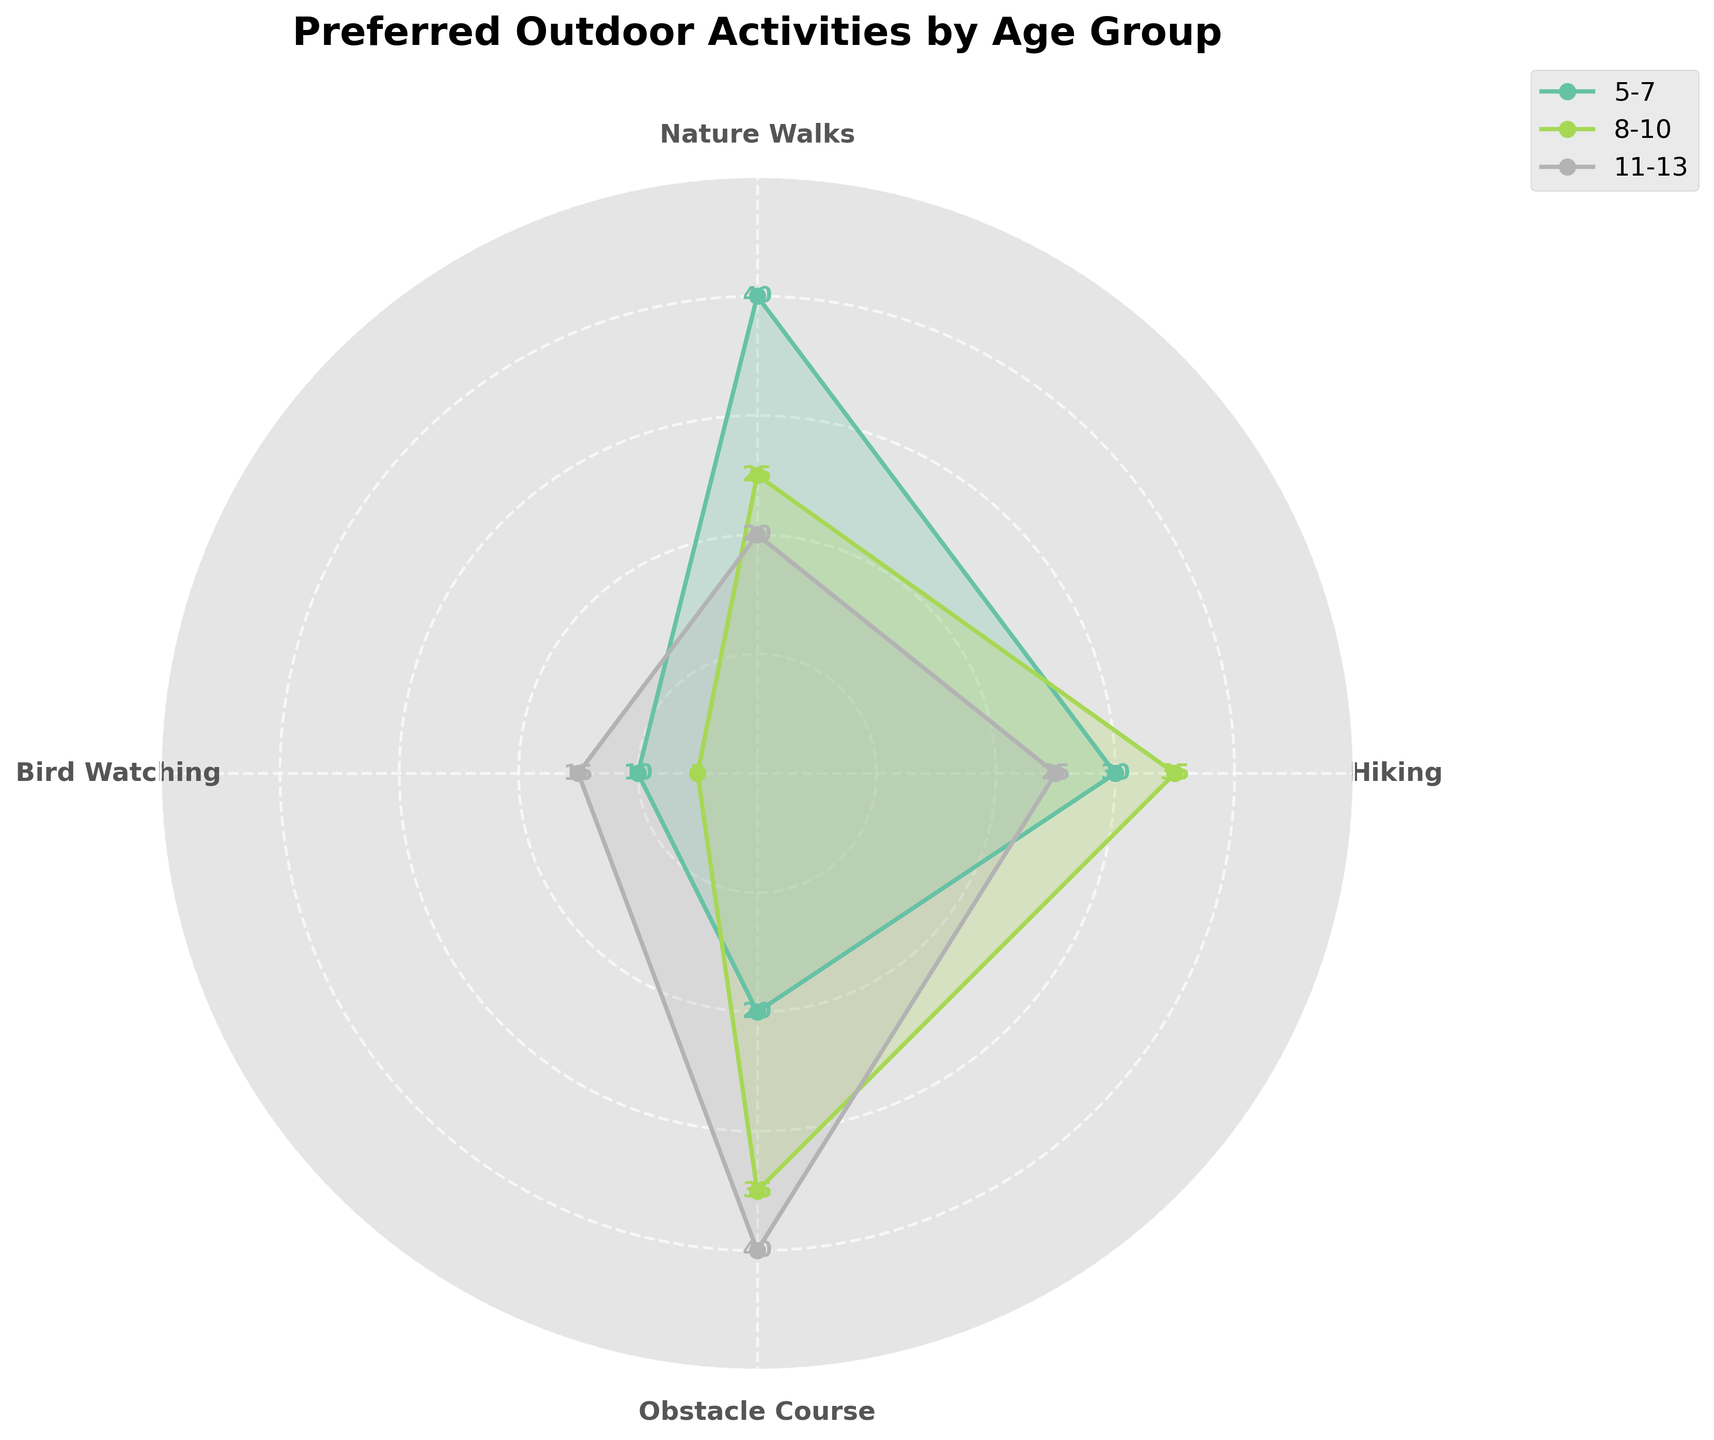What are the age groups shown in the figure? The figure has labeled regions representing different age groups. You can see three age groups: 5-7, 8-10, and 11-13.
Answer: 5-7, 8-10, 11-13 Which activity has the highest preference score for the 5-7 age group? By looking at the plot, you can identify that Nature Walks has the highest score because it is the most extended segment for the 5-7 age group.
Answer: Nature Walks What is the total preference score for Bird Watching across all age groups? Sum the Bird Watching scores from each age group: 10 (5-7) + 5 (8-10) + 15 (11-13) = 30.
Answer: 30 How does the preference for Hiking change among the age groups? Compare the heights of the segments for Hiking. It is 30 for age group 5-7, 35 for 8-10, and 25 for 11-13, indicating a slight increase and then a decrease.
Answer: Increases from 5-7 to 8-10, then decreases for 11-13 Which age group shows the least interest in Bird Watching? Look for the smallest segment in Bird Watching across age groups; it is 8-10 with a score of 5.
Answer: 8-10 What activities have higher preference scores for the 11-13 age group compared to the 8-10 age group? Compare the scores for each activity across these age groups. Obstacle Course (40 vs 35) and Bird Watching (15 vs 5) are higher for 11-13.
Answer: Obstacle Course, Bird Watching What is the average preference score for Obstacle Course across all age groups? Average the scores: (20+35+40)/3 = 95/3 ≈ 31.67.
Answer: 31.67 Which activity shows a similar preference score between the 5-7 and 11-13 age groups? Look for similar segment lengths. Hiking scores are 30 for 5-7 and 25 for 11-13, which are close.
Answer: Hiking What is the difference in the preference score for Nature Walks between the age groups 5-7 and 8-10? Subtract the Nature Walks scores for these age groups: 40 - 25 = 15.
Answer: 15 What pattern can be observed about the preference for Obstacle Course with increasing age? Analyze the pattern of segments; Obstacle Course preference generally increases with age: (20 for 5-7, 35 for 8-10, and 40 for 11-13).
Answer: Increases with age 